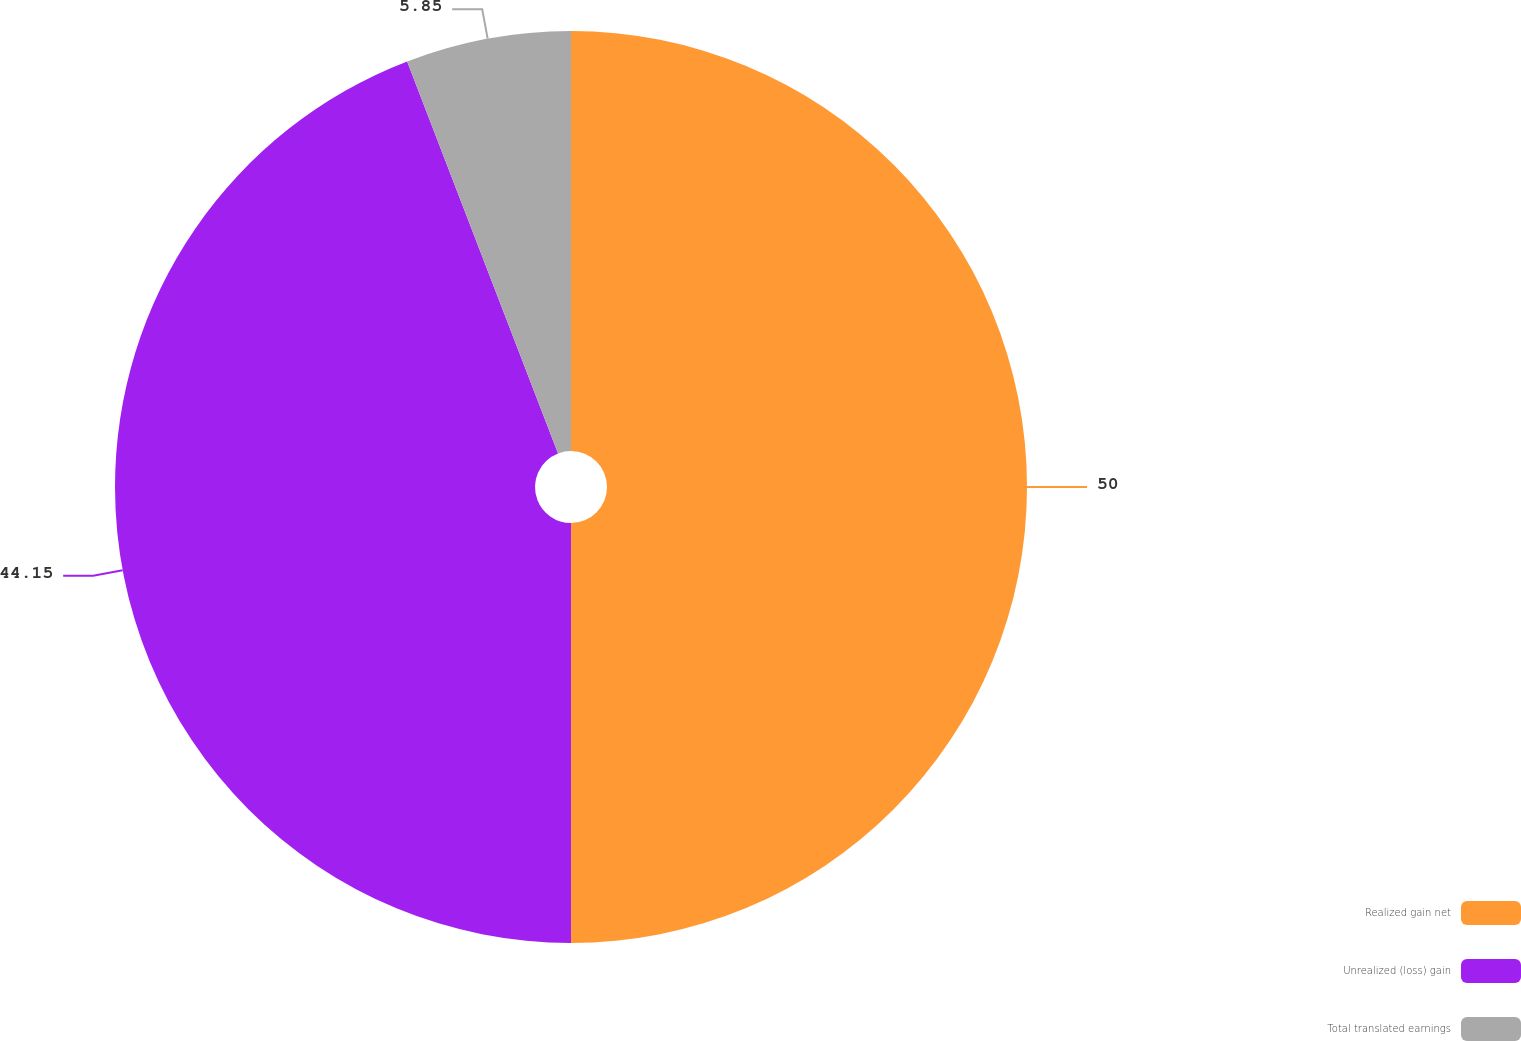Convert chart to OTSL. <chart><loc_0><loc_0><loc_500><loc_500><pie_chart><fcel>Realized gain net<fcel>Unrealized (loss) gain<fcel>Total translated earnings<nl><fcel>50.0%<fcel>44.15%<fcel>5.85%<nl></chart> 